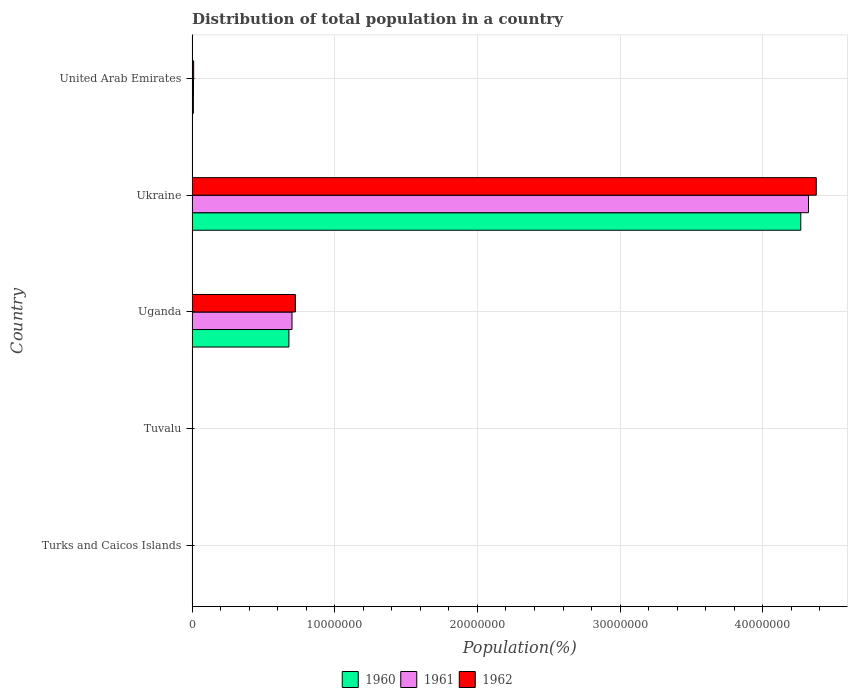How many different coloured bars are there?
Provide a short and direct response. 3. How many groups of bars are there?
Your response must be concise. 5. Are the number of bars on each tick of the Y-axis equal?
Provide a short and direct response. Yes. How many bars are there on the 5th tick from the top?
Your answer should be compact. 3. What is the label of the 4th group of bars from the top?
Your response must be concise. Tuvalu. In how many cases, is the number of bars for a given country not equal to the number of legend labels?
Your answer should be very brief. 0. What is the population of in 1961 in United Arab Emirates?
Keep it short and to the point. 1.01e+05. Across all countries, what is the maximum population of in 1962?
Your response must be concise. 4.37e+07. Across all countries, what is the minimum population of in 1961?
Provide a short and direct response. 5760. In which country was the population of in 1962 maximum?
Offer a very short reply. Ukraine. In which country was the population of in 1962 minimum?
Keep it short and to the point. Turks and Caicos Islands. What is the total population of in 1960 in the graph?
Make the answer very short. 4.96e+07. What is the difference between the population of in 1960 in Uganda and that in Ukraine?
Provide a succinct answer. -3.59e+07. What is the difference between the population of in 1960 in Tuvalu and the population of in 1961 in Ukraine?
Your answer should be very brief. -4.32e+07. What is the average population of in 1961 per country?
Keep it short and to the point. 1.01e+07. What is the difference between the population of in 1961 and population of in 1962 in United Arab Emirates?
Offer a very short reply. -1.13e+04. In how many countries, is the population of in 1960 greater than 30000000 %?
Provide a short and direct response. 1. What is the ratio of the population of in 1961 in Turks and Caicos Islands to that in Tuvalu?
Make the answer very short. 0.92. Is the population of in 1960 in Turks and Caicos Islands less than that in Uganda?
Ensure brevity in your answer.  Yes. Is the difference between the population of in 1961 in Turks and Caicos Islands and Uganda greater than the difference between the population of in 1962 in Turks and Caicos Islands and Uganda?
Ensure brevity in your answer.  Yes. What is the difference between the highest and the second highest population of in 1961?
Provide a short and direct response. 3.62e+07. What is the difference between the highest and the lowest population of in 1960?
Your response must be concise. 4.27e+07. What does the 1st bar from the top in Tuvalu represents?
Keep it short and to the point. 1962. Is it the case that in every country, the sum of the population of in 1962 and population of in 1961 is greater than the population of in 1960?
Offer a very short reply. Yes. Are all the bars in the graph horizontal?
Provide a short and direct response. Yes. What is the difference between two consecutive major ticks on the X-axis?
Make the answer very short. 1.00e+07. Are the values on the major ticks of X-axis written in scientific E-notation?
Provide a succinct answer. No. Does the graph contain grids?
Make the answer very short. Yes. What is the title of the graph?
Offer a terse response. Distribution of total population in a country. What is the label or title of the X-axis?
Your answer should be very brief. Population(%). What is the Population(%) in 1960 in Turks and Caicos Islands?
Your response must be concise. 5724. What is the Population(%) of 1961 in Turks and Caicos Islands?
Provide a succinct answer. 5760. What is the Population(%) in 1962 in Turks and Caicos Islands?
Offer a very short reply. 5762. What is the Population(%) of 1960 in Tuvalu?
Your answer should be very brief. 6104. What is the Population(%) in 1961 in Tuvalu?
Provide a short and direct response. 6242. What is the Population(%) of 1962 in Tuvalu?
Your answer should be compact. 6391. What is the Population(%) of 1960 in Uganda?
Provide a succinct answer. 6.79e+06. What is the Population(%) of 1961 in Uganda?
Offer a very short reply. 7.01e+06. What is the Population(%) in 1962 in Uganda?
Offer a terse response. 7.24e+06. What is the Population(%) in 1960 in Ukraine?
Give a very brief answer. 4.27e+07. What is the Population(%) in 1961 in Ukraine?
Your answer should be very brief. 4.32e+07. What is the Population(%) of 1962 in Ukraine?
Provide a short and direct response. 4.37e+07. What is the Population(%) in 1960 in United Arab Emirates?
Offer a terse response. 9.26e+04. What is the Population(%) in 1961 in United Arab Emirates?
Your answer should be very brief. 1.01e+05. What is the Population(%) of 1962 in United Arab Emirates?
Keep it short and to the point. 1.12e+05. Across all countries, what is the maximum Population(%) in 1960?
Your answer should be compact. 4.27e+07. Across all countries, what is the maximum Population(%) of 1961?
Offer a very short reply. 4.32e+07. Across all countries, what is the maximum Population(%) of 1962?
Give a very brief answer. 4.37e+07. Across all countries, what is the minimum Population(%) of 1960?
Make the answer very short. 5724. Across all countries, what is the minimum Population(%) of 1961?
Make the answer very short. 5760. Across all countries, what is the minimum Population(%) of 1962?
Your answer should be compact. 5762. What is the total Population(%) of 1960 in the graph?
Provide a succinct answer. 4.96e+07. What is the total Population(%) of 1961 in the graph?
Ensure brevity in your answer.  5.03e+07. What is the total Population(%) in 1962 in the graph?
Your answer should be compact. 5.11e+07. What is the difference between the Population(%) of 1960 in Turks and Caicos Islands and that in Tuvalu?
Keep it short and to the point. -380. What is the difference between the Population(%) of 1961 in Turks and Caicos Islands and that in Tuvalu?
Provide a short and direct response. -482. What is the difference between the Population(%) in 1962 in Turks and Caicos Islands and that in Tuvalu?
Offer a terse response. -629. What is the difference between the Population(%) of 1960 in Turks and Caicos Islands and that in Uganda?
Make the answer very short. -6.78e+06. What is the difference between the Population(%) of 1961 in Turks and Caicos Islands and that in Uganda?
Ensure brevity in your answer.  -7.00e+06. What is the difference between the Population(%) of 1962 in Turks and Caicos Islands and that in Uganda?
Provide a succinct answer. -7.23e+06. What is the difference between the Population(%) of 1960 in Turks and Caicos Islands and that in Ukraine?
Your answer should be very brief. -4.27e+07. What is the difference between the Population(%) of 1961 in Turks and Caicos Islands and that in Ukraine?
Offer a terse response. -4.32e+07. What is the difference between the Population(%) of 1962 in Turks and Caicos Islands and that in Ukraine?
Make the answer very short. -4.37e+07. What is the difference between the Population(%) of 1960 in Turks and Caicos Islands and that in United Arab Emirates?
Ensure brevity in your answer.  -8.69e+04. What is the difference between the Population(%) in 1961 in Turks and Caicos Islands and that in United Arab Emirates?
Provide a succinct answer. -9.52e+04. What is the difference between the Population(%) in 1962 in Turks and Caicos Islands and that in United Arab Emirates?
Provide a succinct answer. -1.06e+05. What is the difference between the Population(%) in 1960 in Tuvalu and that in Uganda?
Ensure brevity in your answer.  -6.78e+06. What is the difference between the Population(%) in 1961 in Tuvalu and that in Uganda?
Your answer should be very brief. -7.00e+06. What is the difference between the Population(%) in 1962 in Tuvalu and that in Uganda?
Your answer should be compact. -7.23e+06. What is the difference between the Population(%) of 1960 in Tuvalu and that in Ukraine?
Offer a terse response. -4.27e+07. What is the difference between the Population(%) in 1961 in Tuvalu and that in Ukraine?
Offer a very short reply. -4.32e+07. What is the difference between the Population(%) of 1962 in Tuvalu and that in Ukraine?
Make the answer very short. -4.37e+07. What is the difference between the Population(%) of 1960 in Tuvalu and that in United Arab Emirates?
Keep it short and to the point. -8.65e+04. What is the difference between the Population(%) of 1961 in Tuvalu and that in United Arab Emirates?
Provide a succinct answer. -9.47e+04. What is the difference between the Population(%) in 1962 in Tuvalu and that in United Arab Emirates?
Make the answer very short. -1.06e+05. What is the difference between the Population(%) of 1960 in Uganda and that in Ukraine?
Offer a very short reply. -3.59e+07. What is the difference between the Population(%) of 1961 in Uganda and that in Ukraine?
Provide a succinct answer. -3.62e+07. What is the difference between the Population(%) in 1962 in Uganda and that in Ukraine?
Your response must be concise. -3.65e+07. What is the difference between the Population(%) in 1960 in Uganda and that in United Arab Emirates?
Make the answer very short. 6.70e+06. What is the difference between the Population(%) in 1961 in Uganda and that in United Arab Emirates?
Keep it short and to the point. 6.91e+06. What is the difference between the Population(%) in 1962 in Uganda and that in United Arab Emirates?
Offer a very short reply. 7.13e+06. What is the difference between the Population(%) of 1960 in Ukraine and that in United Arab Emirates?
Your response must be concise. 4.26e+07. What is the difference between the Population(%) in 1961 in Ukraine and that in United Arab Emirates?
Provide a short and direct response. 4.31e+07. What is the difference between the Population(%) in 1962 in Ukraine and that in United Arab Emirates?
Your answer should be very brief. 4.36e+07. What is the difference between the Population(%) of 1960 in Turks and Caicos Islands and the Population(%) of 1961 in Tuvalu?
Your answer should be compact. -518. What is the difference between the Population(%) of 1960 in Turks and Caicos Islands and the Population(%) of 1962 in Tuvalu?
Offer a very short reply. -667. What is the difference between the Population(%) in 1961 in Turks and Caicos Islands and the Population(%) in 1962 in Tuvalu?
Offer a terse response. -631. What is the difference between the Population(%) of 1960 in Turks and Caicos Islands and the Population(%) of 1961 in Uganda?
Provide a short and direct response. -7.00e+06. What is the difference between the Population(%) in 1960 in Turks and Caicos Islands and the Population(%) in 1962 in Uganda?
Your answer should be compact. -7.23e+06. What is the difference between the Population(%) of 1961 in Turks and Caicos Islands and the Population(%) of 1962 in Uganda?
Make the answer very short. -7.23e+06. What is the difference between the Population(%) in 1960 in Turks and Caicos Islands and the Population(%) in 1961 in Ukraine?
Offer a terse response. -4.32e+07. What is the difference between the Population(%) in 1960 in Turks and Caicos Islands and the Population(%) in 1962 in Ukraine?
Your response must be concise. -4.37e+07. What is the difference between the Population(%) in 1961 in Turks and Caicos Islands and the Population(%) in 1962 in Ukraine?
Offer a terse response. -4.37e+07. What is the difference between the Population(%) in 1960 in Turks and Caicos Islands and the Population(%) in 1961 in United Arab Emirates?
Make the answer very short. -9.53e+04. What is the difference between the Population(%) in 1960 in Turks and Caicos Islands and the Population(%) in 1962 in United Arab Emirates?
Ensure brevity in your answer.  -1.07e+05. What is the difference between the Population(%) in 1961 in Turks and Caicos Islands and the Population(%) in 1962 in United Arab Emirates?
Give a very brief answer. -1.06e+05. What is the difference between the Population(%) of 1960 in Tuvalu and the Population(%) of 1961 in Uganda?
Make the answer very short. -7.00e+06. What is the difference between the Population(%) in 1960 in Tuvalu and the Population(%) in 1962 in Uganda?
Provide a succinct answer. -7.23e+06. What is the difference between the Population(%) of 1961 in Tuvalu and the Population(%) of 1962 in Uganda?
Your answer should be very brief. -7.23e+06. What is the difference between the Population(%) of 1960 in Tuvalu and the Population(%) of 1961 in Ukraine?
Your response must be concise. -4.32e+07. What is the difference between the Population(%) in 1960 in Tuvalu and the Population(%) in 1962 in Ukraine?
Provide a short and direct response. -4.37e+07. What is the difference between the Population(%) of 1961 in Tuvalu and the Population(%) of 1962 in Ukraine?
Provide a succinct answer. -4.37e+07. What is the difference between the Population(%) in 1960 in Tuvalu and the Population(%) in 1961 in United Arab Emirates?
Provide a short and direct response. -9.49e+04. What is the difference between the Population(%) of 1960 in Tuvalu and the Population(%) of 1962 in United Arab Emirates?
Your response must be concise. -1.06e+05. What is the difference between the Population(%) of 1961 in Tuvalu and the Population(%) of 1962 in United Arab Emirates?
Provide a short and direct response. -1.06e+05. What is the difference between the Population(%) of 1960 in Uganda and the Population(%) of 1961 in Ukraine?
Your answer should be very brief. -3.64e+07. What is the difference between the Population(%) in 1960 in Uganda and the Population(%) in 1962 in Ukraine?
Your answer should be compact. -3.70e+07. What is the difference between the Population(%) in 1961 in Uganda and the Population(%) in 1962 in Ukraine?
Your answer should be very brief. -3.67e+07. What is the difference between the Population(%) of 1960 in Uganda and the Population(%) of 1961 in United Arab Emirates?
Provide a short and direct response. 6.69e+06. What is the difference between the Population(%) in 1960 in Uganda and the Population(%) in 1962 in United Arab Emirates?
Provide a short and direct response. 6.68e+06. What is the difference between the Population(%) of 1961 in Uganda and the Population(%) of 1962 in United Arab Emirates?
Your answer should be compact. 6.89e+06. What is the difference between the Population(%) of 1960 in Ukraine and the Population(%) of 1961 in United Arab Emirates?
Offer a terse response. 4.26e+07. What is the difference between the Population(%) in 1960 in Ukraine and the Population(%) in 1962 in United Arab Emirates?
Your response must be concise. 4.25e+07. What is the difference between the Population(%) in 1961 in Ukraine and the Population(%) in 1962 in United Arab Emirates?
Offer a very short reply. 4.31e+07. What is the average Population(%) of 1960 per country?
Make the answer very short. 9.91e+06. What is the average Population(%) of 1961 per country?
Provide a succinct answer. 1.01e+07. What is the average Population(%) of 1962 per country?
Make the answer very short. 1.02e+07. What is the difference between the Population(%) in 1960 and Population(%) in 1961 in Turks and Caicos Islands?
Ensure brevity in your answer.  -36. What is the difference between the Population(%) of 1960 and Population(%) of 1962 in Turks and Caicos Islands?
Your answer should be very brief. -38. What is the difference between the Population(%) in 1961 and Population(%) in 1962 in Turks and Caicos Islands?
Provide a short and direct response. -2. What is the difference between the Population(%) in 1960 and Population(%) in 1961 in Tuvalu?
Offer a terse response. -138. What is the difference between the Population(%) in 1960 and Population(%) in 1962 in Tuvalu?
Your answer should be very brief. -287. What is the difference between the Population(%) in 1961 and Population(%) in 1962 in Tuvalu?
Your answer should be compact. -149. What is the difference between the Population(%) in 1960 and Population(%) in 1961 in Uganda?
Ensure brevity in your answer.  -2.18e+05. What is the difference between the Population(%) in 1960 and Population(%) in 1962 in Uganda?
Keep it short and to the point. -4.52e+05. What is the difference between the Population(%) of 1961 and Population(%) of 1962 in Uganda?
Offer a terse response. -2.34e+05. What is the difference between the Population(%) of 1960 and Population(%) of 1961 in Ukraine?
Your response must be concise. -5.41e+05. What is the difference between the Population(%) of 1960 and Population(%) of 1962 in Ukraine?
Give a very brief answer. -1.09e+06. What is the difference between the Population(%) in 1961 and Population(%) in 1962 in Ukraine?
Give a very brief answer. -5.46e+05. What is the difference between the Population(%) of 1960 and Population(%) of 1961 in United Arab Emirates?
Your answer should be compact. -8373. What is the difference between the Population(%) of 1960 and Population(%) of 1962 in United Arab Emirates?
Provide a short and direct response. -1.96e+04. What is the difference between the Population(%) in 1961 and Population(%) in 1962 in United Arab Emirates?
Give a very brief answer. -1.13e+04. What is the ratio of the Population(%) of 1960 in Turks and Caicos Islands to that in Tuvalu?
Offer a very short reply. 0.94. What is the ratio of the Population(%) in 1961 in Turks and Caicos Islands to that in Tuvalu?
Provide a short and direct response. 0.92. What is the ratio of the Population(%) of 1962 in Turks and Caicos Islands to that in Tuvalu?
Provide a succinct answer. 0.9. What is the ratio of the Population(%) of 1960 in Turks and Caicos Islands to that in Uganda?
Make the answer very short. 0. What is the ratio of the Population(%) in 1961 in Turks and Caicos Islands to that in Uganda?
Provide a short and direct response. 0. What is the ratio of the Population(%) in 1962 in Turks and Caicos Islands to that in Uganda?
Offer a terse response. 0. What is the ratio of the Population(%) of 1961 in Turks and Caicos Islands to that in Ukraine?
Provide a short and direct response. 0. What is the ratio of the Population(%) of 1960 in Turks and Caicos Islands to that in United Arab Emirates?
Your response must be concise. 0.06. What is the ratio of the Population(%) in 1961 in Turks and Caicos Islands to that in United Arab Emirates?
Your answer should be compact. 0.06. What is the ratio of the Population(%) in 1962 in Turks and Caicos Islands to that in United Arab Emirates?
Offer a terse response. 0.05. What is the ratio of the Population(%) in 1960 in Tuvalu to that in Uganda?
Offer a very short reply. 0. What is the ratio of the Population(%) of 1961 in Tuvalu to that in Uganda?
Your answer should be very brief. 0. What is the ratio of the Population(%) of 1962 in Tuvalu to that in Uganda?
Offer a very short reply. 0. What is the ratio of the Population(%) in 1960 in Tuvalu to that in Ukraine?
Keep it short and to the point. 0. What is the ratio of the Population(%) in 1961 in Tuvalu to that in Ukraine?
Ensure brevity in your answer.  0. What is the ratio of the Population(%) in 1960 in Tuvalu to that in United Arab Emirates?
Provide a short and direct response. 0.07. What is the ratio of the Population(%) of 1961 in Tuvalu to that in United Arab Emirates?
Keep it short and to the point. 0.06. What is the ratio of the Population(%) of 1962 in Tuvalu to that in United Arab Emirates?
Make the answer very short. 0.06. What is the ratio of the Population(%) in 1960 in Uganda to that in Ukraine?
Offer a very short reply. 0.16. What is the ratio of the Population(%) in 1961 in Uganda to that in Ukraine?
Offer a very short reply. 0.16. What is the ratio of the Population(%) of 1962 in Uganda to that in Ukraine?
Your answer should be very brief. 0.17. What is the ratio of the Population(%) of 1960 in Uganda to that in United Arab Emirates?
Provide a short and direct response. 73.3. What is the ratio of the Population(%) in 1961 in Uganda to that in United Arab Emirates?
Your answer should be compact. 69.38. What is the ratio of the Population(%) of 1962 in Uganda to that in United Arab Emirates?
Offer a very short reply. 64.51. What is the ratio of the Population(%) of 1960 in Ukraine to that in United Arab Emirates?
Give a very brief answer. 460.65. What is the ratio of the Population(%) of 1961 in Ukraine to that in United Arab Emirates?
Your answer should be very brief. 427.82. What is the ratio of the Population(%) of 1962 in Ukraine to that in United Arab Emirates?
Make the answer very short. 389.79. What is the difference between the highest and the second highest Population(%) of 1960?
Your response must be concise. 3.59e+07. What is the difference between the highest and the second highest Population(%) in 1961?
Give a very brief answer. 3.62e+07. What is the difference between the highest and the second highest Population(%) in 1962?
Give a very brief answer. 3.65e+07. What is the difference between the highest and the lowest Population(%) in 1960?
Your answer should be very brief. 4.27e+07. What is the difference between the highest and the lowest Population(%) in 1961?
Make the answer very short. 4.32e+07. What is the difference between the highest and the lowest Population(%) in 1962?
Your answer should be very brief. 4.37e+07. 